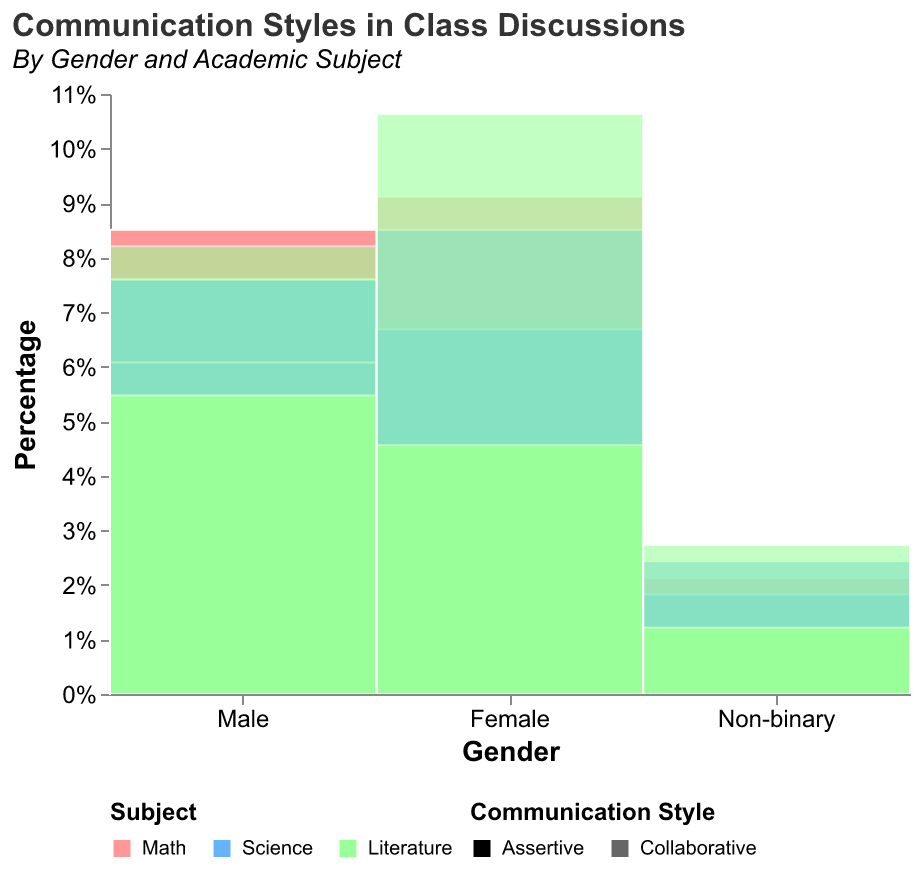What is the title of the figure? The title is usually located at the top of the figure. It summarizes the content of the graph.
Answer: Communication Styles in Class Discussions Which gender group has the highest percentage of collaborative communication style in Literature? In the figure, find the 'Literature' section under each gender, then check which has the largest section with the 'Collaborative' communication style shading.
Answer: Female What percentage of assertive communication style is used by males in Math? Look for the 'Math' category under the 'Male' group and identify the percentage bar for 'Assertive' communication style. The tooltip or the bar height should indicate the percentage.
Answer: 56% How do the communication styles of males and females compare in Science? Compare the height of the 'Science' sections for each gender in 'Assertive' and 'Collaborative' communication styles.
Answer: Males use more assertive, females use more collaborative Which subject has the smallest usage of assertive communication style by non-binary students? Check all subjects under the 'Non-binary' category for the smallest percentage bar in assertive communication style.
Answer: Literature How does the overall count of assertive versus collaborative communication style compare for all genders in Math? Sum the percentages of 'Assertive' and 'Collaborative' styles across all genders for the Math category, then compare the sums.
Answer: Collaborative > Assertive In which subject do females have the highest percentage of assertive communication? Among the categories 'Math', 'Science', and 'Literature' under the 'Female' section, identify the highest 'Assertive' percentage.
Answer: Science What is the ratio of collaborative communication style to assertive communication style for males in Literature? Find the 'Collaborative' and 'Assertive' percentages in the 'Literature' section under 'Male' and calculate the ratio.
Answer: 27/18 or 1.5 How does the use of assertive communication style in Science differ between males and non-binary individuals? Compare the 'Assertive' communication percentage in the 'Science' section for 'Male' and 'Non-binary' groups.
Answer: 25% (Male) vs 6% (Non-binary) Which gender-subject combination has the highest overall percentage of collaborative communication? Look for the highest 'Collaborative' percentage bar across all gender and subject combinations.
Answer: Female-Literature 